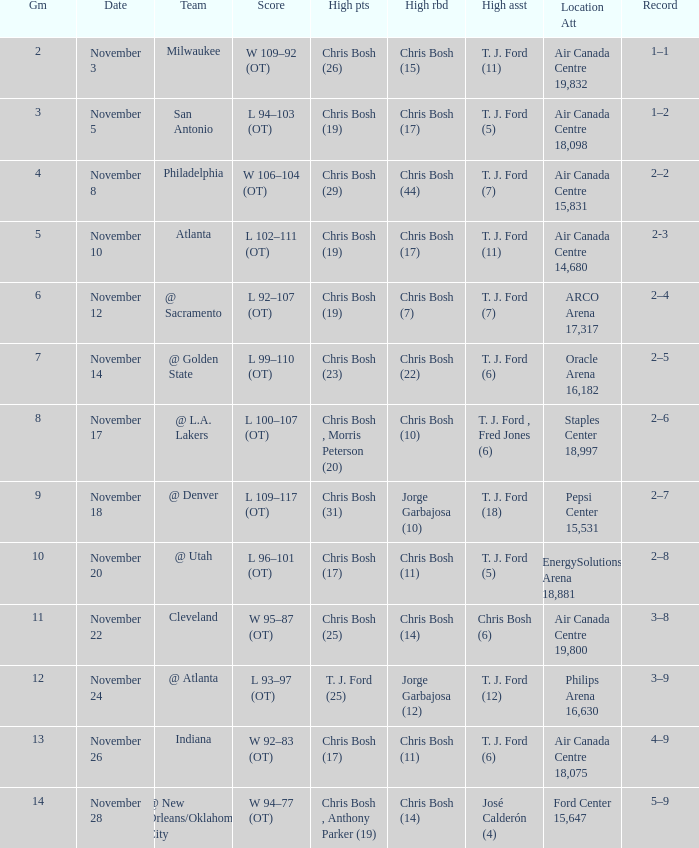What was the score of the game on November 12? L 92–107 (OT). 